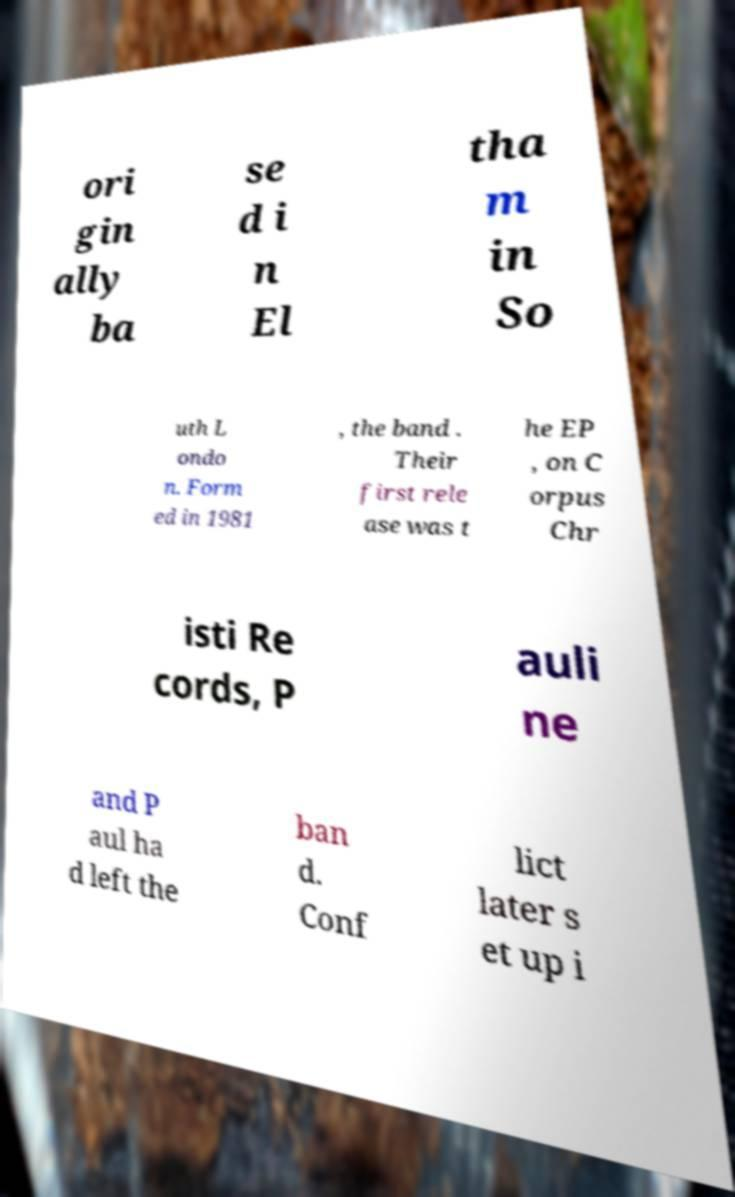Can you accurately transcribe the text from the provided image for me? ori gin ally ba se d i n El tha m in So uth L ondo n. Form ed in 1981 , the band . Their first rele ase was t he EP , on C orpus Chr isti Re cords, P auli ne and P aul ha d left the ban d. Conf lict later s et up i 